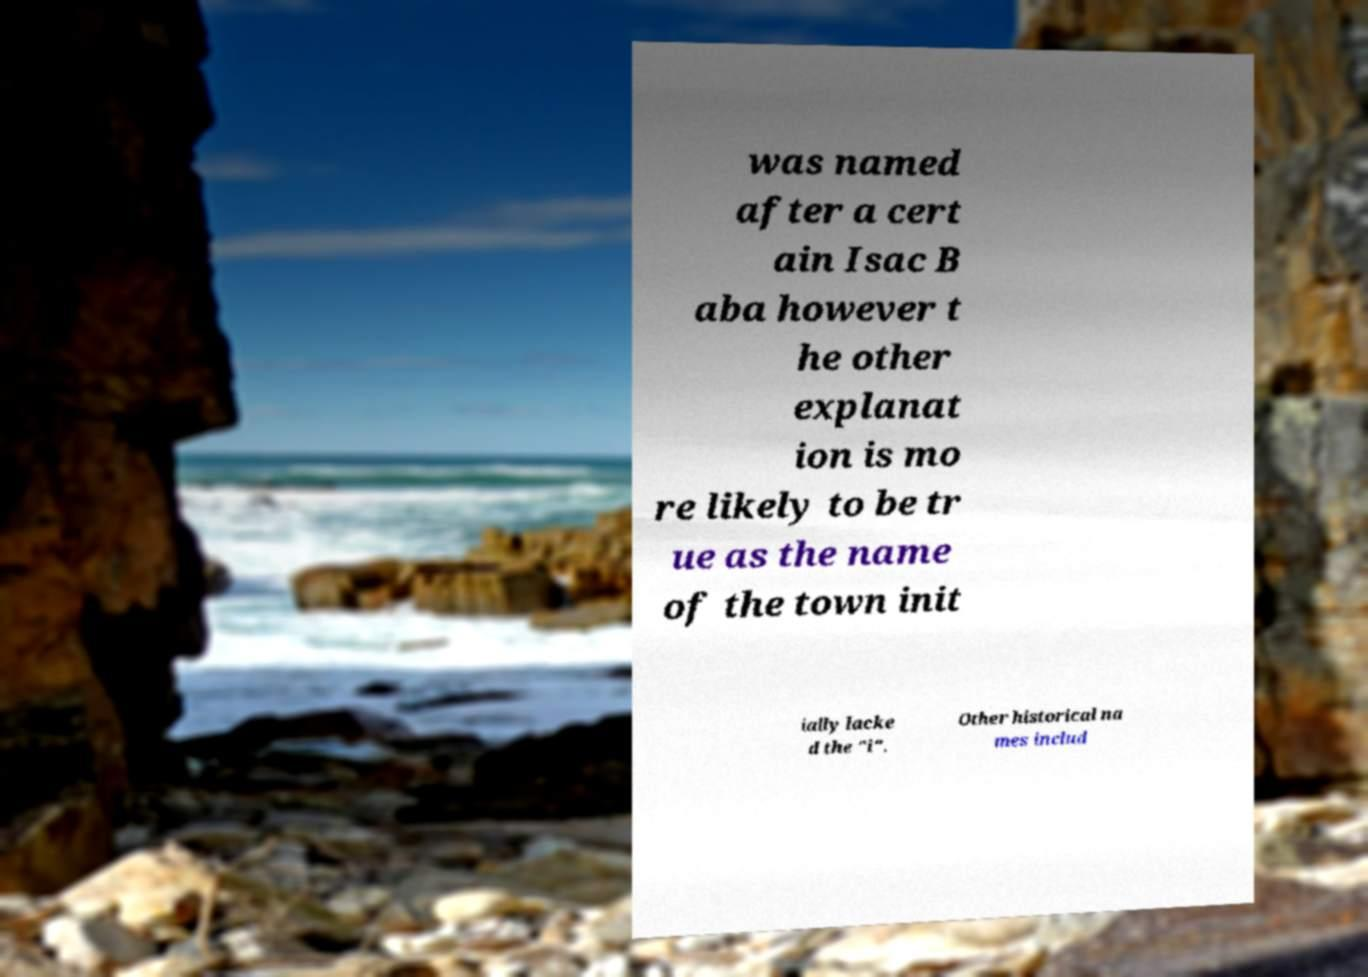What messages or text are displayed in this image? I need them in a readable, typed format. was named after a cert ain Isac B aba however t he other explanat ion is mo re likely to be tr ue as the name of the town init ially lacke d the "i". Other historical na mes includ 